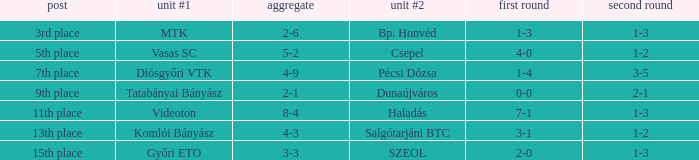What is the team #1 with an 11th place position? Videoton. 